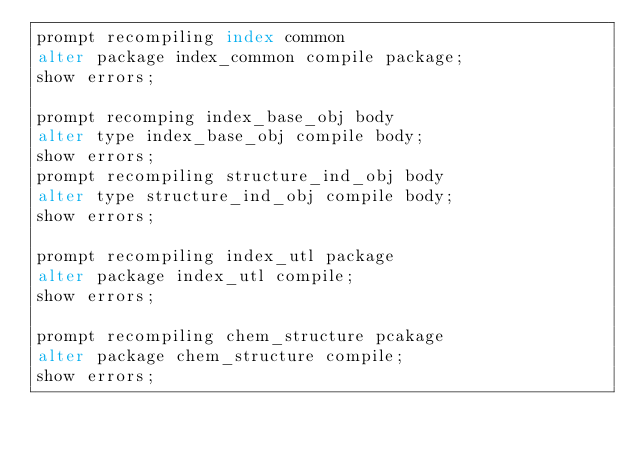<code> <loc_0><loc_0><loc_500><loc_500><_SQL_>prompt recompiling index common
alter package index_common compile package;
show errors;

prompt recomping index_base_obj body
alter type index_base_obj compile body;
show errors;
prompt recompiling structure_ind_obj body
alter type structure_ind_obj compile body;
show errors;

prompt recompiling index_utl package
alter package index_utl compile;
show errors;

prompt recompiling chem_structure pcakage
alter package chem_structure compile;
show errors;

</code> 